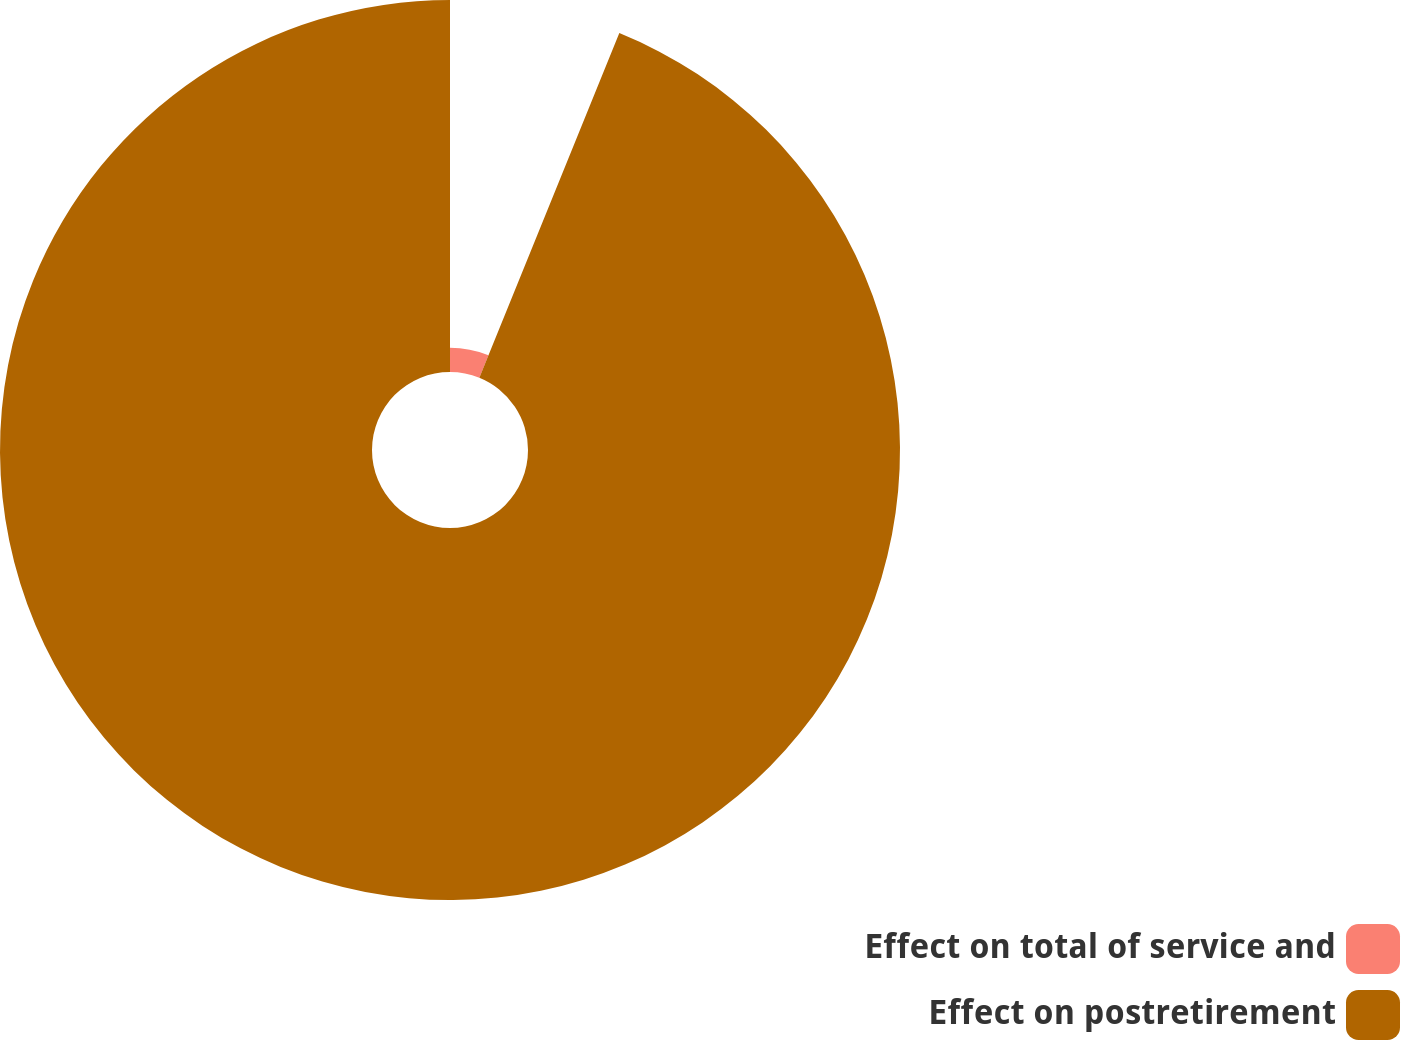Convert chart. <chart><loc_0><loc_0><loc_500><loc_500><pie_chart><fcel>Effect on total of service and<fcel>Effect on postretirement<nl><fcel>6.14%<fcel>93.86%<nl></chart> 